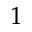Convert formula to latex. <formula><loc_0><loc_0><loc_500><loc_500>^ { 1 }</formula> 